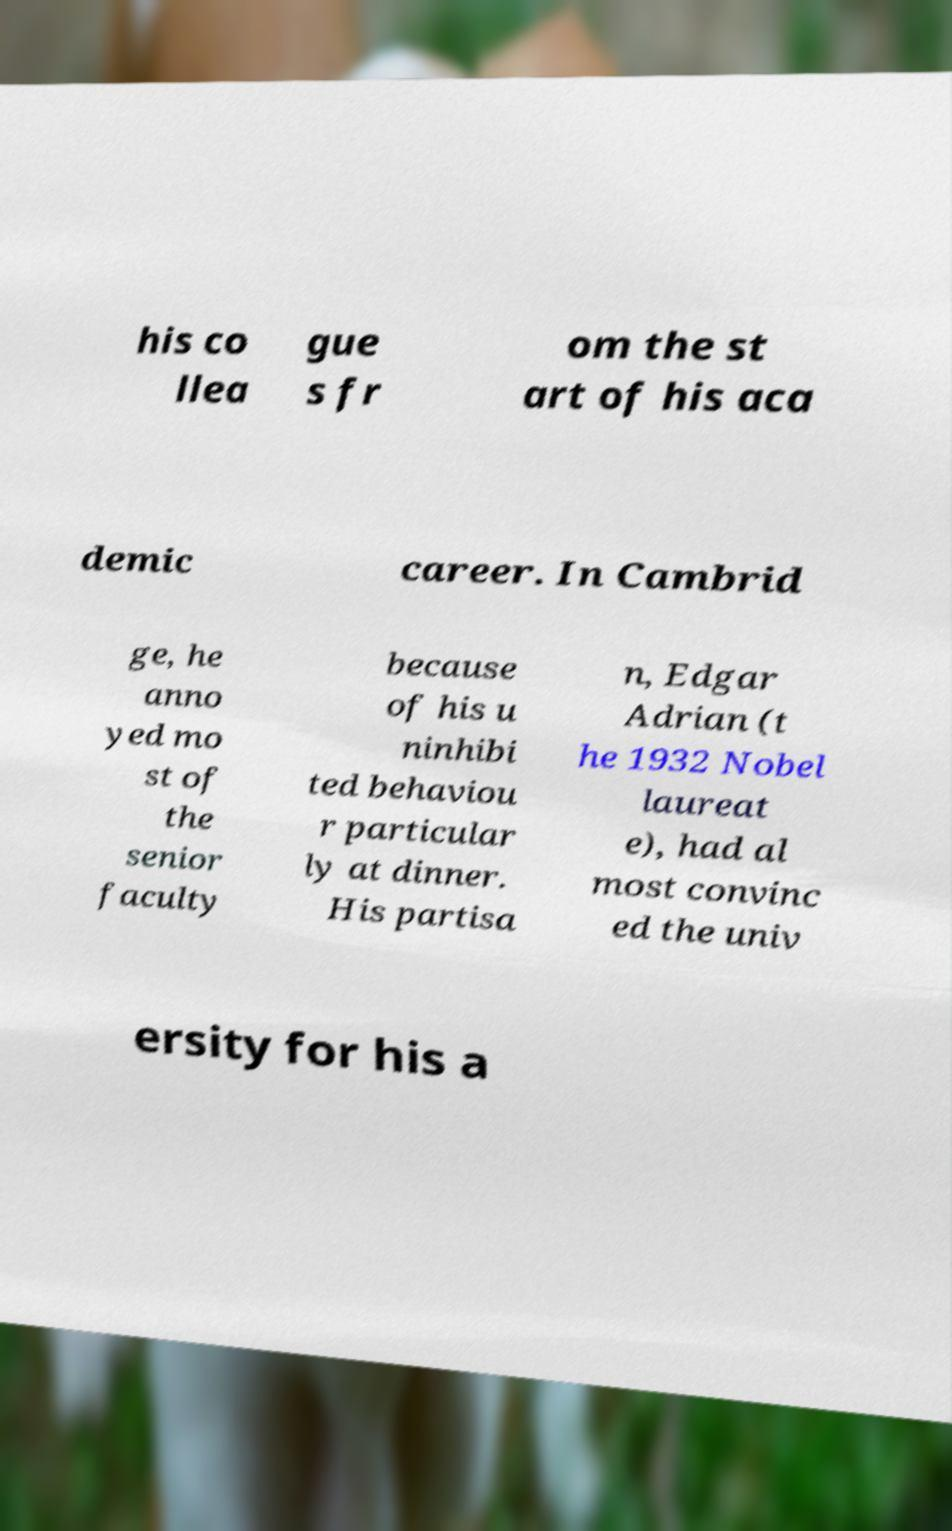Could you assist in decoding the text presented in this image and type it out clearly? his co llea gue s fr om the st art of his aca demic career. In Cambrid ge, he anno yed mo st of the senior faculty because of his u ninhibi ted behaviou r particular ly at dinner. His partisa n, Edgar Adrian (t he 1932 Nobel laureat e), had al most convinc ed the univ ersity for his a 